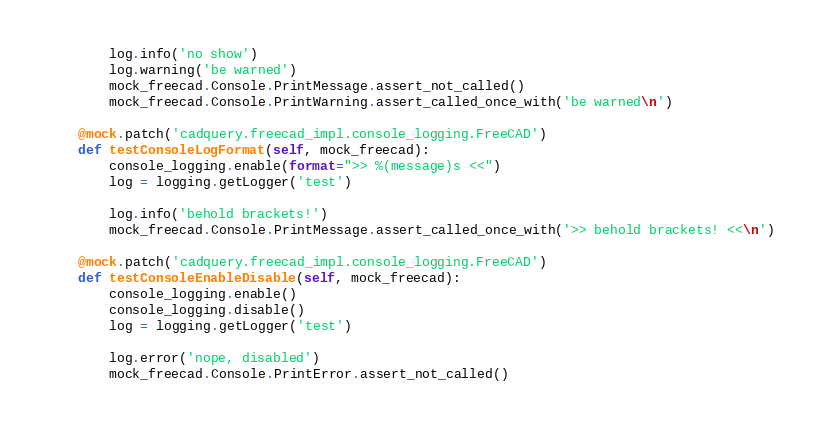<code> <loc_0><loc_0><loc_500><loc_500><_Python_>
        log.info('no show')
        log.warning('be warned')
        mock_freecad.Console.PrintMessage.assert_not_called()
        mock_freecad.Console.PrintWarning.assert_called_once_with('be warned\n')

    @mock.patch('cadquery.freecad_impl.console_logging.FreeCAD')
    def testConsoleLogFormat(self, mock_freecad):
        console_logging.enable(format=">> %(message)s <<")
        log = logging.getLogger('test')

        log.info('behold brackets!')
        mock_freecad.Console.PrintMessage.assert_called_once_with('>> behold brackets! <<\n')

    @mock.patch('cadquery.freecad_impl.console_logging.FreeCAD')
    def testConsoleEnableDisable(self, mock_freecad):
        console_logging.enable()
        console_logging.disable()
        log = logging.getLogger('test')

        log.error('nope, disabled')
        mock_freecad.Console.PrintError.assert_not_called()
</code> 